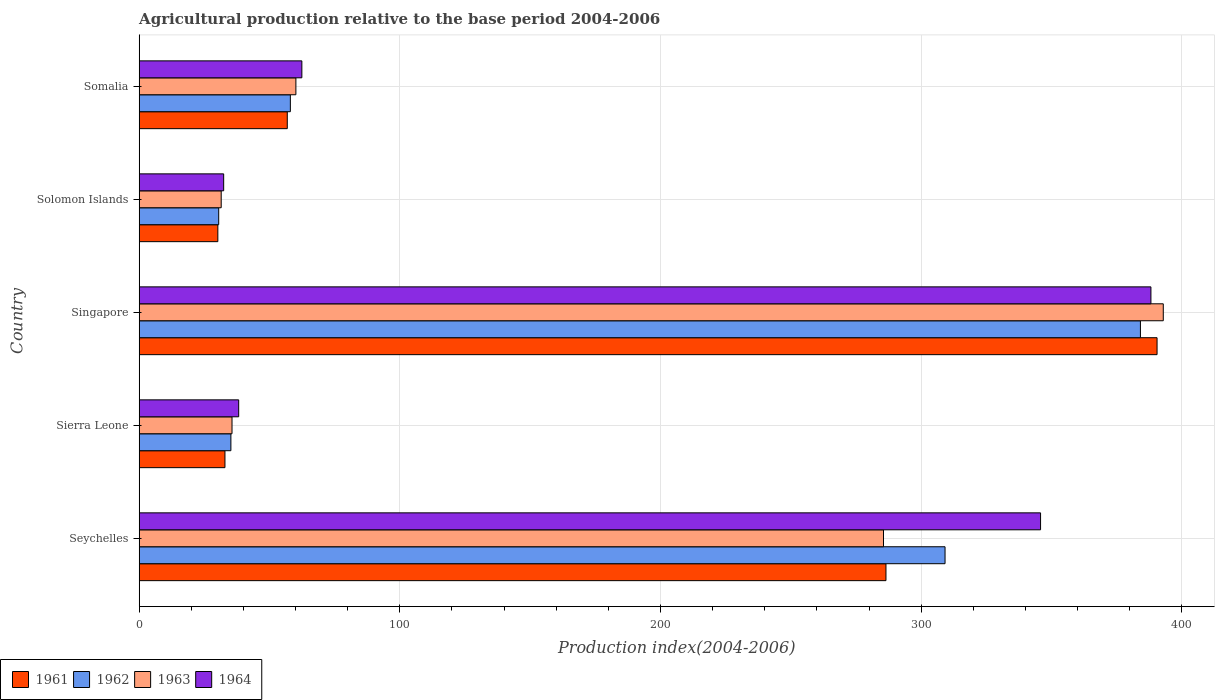Are the number of bars on each tick of the Y-axis equal?
Make the answer very short. Yes. How many bars are there on the 3rd tick from the top?
Make the answer very short. 4. How many bars are there on the 5th tick from the bottom?
Provide a succinct answer. 4. What is the label of the 2nd group of bars from the top?
Your response must be concise. Solomon Islands. What is the agricultural production index in 1964 in Singapore?
Your answer should be compact. 388.12. Across all countries, what is the maximum agricultural production index in 1962?
Give a very brief answer. 384.09. Across all countries, what is the minimum agricultural production index in 1963?
Your response must be concise. 31.47. In which country was the agricultural production index in 1962 maximum?
Give a very brief answer. Singapore. In which country was the agricultural production index in 1961 minimum?
Provide a short and direct response. Solomon Islands. What is the total agricultural production index in 1963 in the graph?
Give a very brief answer. 805.6. What is the difference between the agricultural production index in 1963 in Singapore and that in Somalia?
Give a very brief answer. 332.74. What is the difference between the agricultural production index in 1961 in Somalia and the agricultural production index in 1962 in Singapore?
Provide a short and direct response. -327.27. What is the average agricultural production index in 1964 per country?
Offer a terse response. 173.38. What is the difference between the agricultural production index in 1964 and agricultural production index in 1962 in Singapore?
Your answer should be very brief. 4.03. What is the ratio of the agricultural production index in 1963 in Seychelles to that in Somalia?
Keep it short and to the point. 4.75. Is the agricultural production index in 1963 in Sierra Leone less than that in Singapore?
Your response must be concise. Yes. Is the difference between the agricultural production index in 1964 in Singapore and Somalia greater than the difference between the agricultural production index in 1962 in Singapore and Somalia?
Your answer should be very brief. No. What is the difference between the highest and the second highest agricultural production index in 1964?
Make the answer very short. 42.34. What is the difference between the highest and the lowest agricultural production index in 1961?
Make the answer very short. 360.29. Is the sum of the agricultural production index in 1962 in Singapore and Somalia greater than the maximum agricultural production index in 1963 across all countries?
Your answer should be very brief. Yes. Is it the case that in every country, the sum of the agricultural production index in 1963 and agricultural production index in 1962 is greater than the sum of agricultural production index in 1964 and agricultural production index in 1961?
Provide a short and direct response. No. What does the 4th bar from the bottom in Somalia represents?
Ensure brevity in your answer.  1964. Is it the case that in every country, the sum of the agricultural production index in 1963 and agricultural production index in 1962 is greater than the agricultural production index in 1964?
Make the answer very short. Yes. How many bars are there?
Your answer should be compact. 20. What is the difference between two consecutive major ticks on the X-axis?
Give a very brief answer. 100. Does the graph contain any zero values?
Your answer should be compact. No. How many legend labels are there?
Make the answer very short. 4. What is the title of the graph?
Your answer should be compact. Agricultural production relative to the base period 2004-2006. What is the label or title of the X-axis?
Provide a short and direct response. Production index(2004-2006). What is the label or title of the Y-axis?
Provide a short and direct response. Country. What is the Production index(2004-2006) in 1961 in Seychelles?
Ensure brevity in your answer.  286.48. What is the Production index(2004-2006) of 1962 in Seychelles?
Your answer should be compact. 309.14. What is the Production index(2004-2006) in 1963 in Seychelles?
Provide a succinct answer. 285.53. What is the Production index(2004-2006) of 1964 in Seychelles?
Give a very brief answer. 345.78. What is the Production index(2004-2006) of 1961 in Sierra Leone?
Your answer should be compact. 32.91. What is the Production index(2004-2006) in 1962 in Sierra Leone?
Provide a short and direct response. 35.19. What is the Production index(2004-2006) in 1963 in Sierra Leone?
Offer a very short reply. 35.62. What is the Production index(2004-2006) in 1964 in Sierra Leone?
Provide a succinct answer. 38.18. What is the Production index(2004-2006) in 1961 in Singapore?
Ensure brevity in your answer.  390.47. What is the Production index(2004-2006) in 1962 in Singapore?
Provide a short and direct response. 384.09. What is the Production index(2004-2006) of 1963 in Singapore?
Offer a terse response. 392.86. What is the Production index(2004-2006) of 1964 in Singapore?
Provide a succinct answer. 388.12. What is the Production index(2004-2006) of 1961 in Solomon Islands?
Offer a very short reply. 30.18. What is the Production index(2004-2006) of 1962 in Solomon Islands?
Your response must be concise. 30.51. What is the Production index(2004-2006) of 1963 in Solomon Islands?
Keep it short and to the point. 31.47. What is the Production index(2004-2006) in 1964 in Solomon Islands?
Make the answer very short. 32.42. What is the Production index(2004-2006) of 1961 in Somalia?
Provide a succinct answer. 56.82. What is the Production index(2004-2006) in 1963 in Somalia?
Give a very brief answer. 60.12. What is the Production index(2004-2006) in 1964 in Somalia?
Your answer should be very brief. 62.41. Across all countries, what is the maximum Production index(2004-2006) in 1961?
Your response must be concise. 390.47. Across all countries, what is the maximum Production index(2004-2006) in 1962?
Your response must be concise. 384.09. Across all countries, what is the maximum Production index(2004-2006) of 1963?
Give a very brief answer. 392.86. Across all countries, what is the maximum Production index(2004-2006) in 1964?
Provide a short and direct response. 388.12. Across all countries, what is the minimum Production index(2004-2006) in 1961?
Ensure brevity in your answer.  30.18. Across all countries, what is the minimum Production index(2004-2006) of 1962?
Ensure brevity in your answer.  30.51. Across all countries, what is the minimum Production index(2004-2006) in 1963?
Provide a succinct answer. 31.47. Across all countries, what is the minimum Production index(2004-2006) in 1964?
Give a very brief answer. 32.42. What is the total Production index(2004-2006) of 1961 in the graph?
Give a very brief answer. 796.86. What is the total Production index(2004-2006) in 1962 in the graph?
Keep it short and to the point. 816.93. What is the total Production index(2004-2006) in 1963 in the graph?
Make the answer very short. 805.6. What is the total Production index(2004-2006) of 1964 in the graph?
Ensure brevity in your answer.  866.91. What is the difference between the Production index(2004-2006) of 1961 in Seychelles and that in Sierra Leone?
Your response must be concise. 253.57. What is the difference between the Production index(2004-2006) of 1962 in Seychelles and that in Sierra Leone?
Provide a short and direct response. 273.95. What is the difference between the Production index(2004-2006) of 1963 in Seychelles and that in Sierra Leone?
Provide a short and direct response. 249.91. What is the difference between the Production index(2004-2006) of 1964 in Seychelles and that in Sierra Leone?
Keep it short and to the point. 307.6. What is the difference between the Production index(2004-2006) in 1961 in Seychelles and that in Singapore?
Offer a very short reply. -103.99. What is the difference between the Production index(2004-2006) in 1962 in Seychelles and that in Singapore?
Offer a very short reply. -74.95. What is the difference between the Production index(2004-2006) in 1963 in Seychelles and that in Singapore?
Provide a short and direct response. -107.33. What is the difference between the Production index(2004-2006) of 1964 in Seychelles and that in Singapore?
Your response must be concise. -42.34. What is the difference between the Production index(2004-2006) in 1961 in Seychelles and that in Solomon Islands?
Make the answer very short. 256.3. What is the difference between the Production index(2004-2006) in 1962 in Seychelles and that in Solomon Islands?
Keep it short and to the point. 278.63. What is the difference between the Production index(2004-2006) in 1963 in Seychelles and that in Solomon Islands?
Your response must be concise. 254.06. What is the difference between the Production index(2004-2006) of 1964 in Seychelles and that in Solomon Islands?
Make the answer very short. 313.36. What is the difference between the Production index(2004-2006) in 1961 in Seychelles and that in Somalia?
Give a very brief answer. 229.66. What is the difference between the Production index(2004-2006) in 1962 in Seychelles and that in Somalia?
Offer a very short reply. 251.14. What is the difference between the Production index(2004-2006) of 1963 in Seychelles and that in Somalia?
Provide a succinct answer. 225.41. What is the difference between the Production index(2004-2006) of 1964 in Seychelles and that in Somalia?
Your response must be concise. 283.37. What is the difference between the Production index(2004-2006) of 1961 in Sierra Leone and that in Singapore?
Offer a terse response. -357.56. What is the difference between the Production index(2004-2006) in 1962 in Sierra Leone and that in Singapore?
Ensure brevity in your answer.  -348.9. What is the difference between the Production index(2004-2006) in 1963 in Sierra Leone and that in Singapore?
Your answer should be very brief. -357.24. What is the difference between the Production index(2004-2006) of 1964 in Sierra Leone and that in Singapore?
Your response must be concise. -349.94. What is the difference between the Production index(2004-2006) of 1961 in Sierra Leone and that in Solomon Islands?
Offer a terse response. 2.73. What is the difference between the Production index(2004-2006) in 1962 in Sierra Leone and that in Solomon Islands?
Your response must be concise. 4.68. What is the difference between the Production index(2004-2006) in 1963 in Sierra Leone and that in Solomon Islands?
Offer a terse response. 4.15. What is the difference between the Production index(2004-2006) of 1964 in Sierra Leone and that in Solomon Islands?
Provide a succinct answer. 5.76. What is the difference between the Production index(2004-2006) in 1961 in Sierra Leone and that in Somalia?
Your answer should be very brief. -23.91. What is the difference between the Production index(2004-2006) of 1962 in Sierra Leone and that in Somalia?
Provide a short and direct response. -22.81. What is the difference between the Production index(2004-2006) of 1963 in Sierra Leone and that in Somalia?
Your answer should be very brief. -24.5. What is the difference between the Production index(2004-2006) in 1964 in Sierra Leone and that in Somalia?
Offer a very short reply. -24.23. What is the difference between the Production index(2004-2006) of 1961 in Singapore and that in Solomon Islands?
Your response must be concise. 360.29. What is the difference between the Production index(2004-2006) in 1962 in Singapore and that in Solomon Islands?
Provide a succinct answer. 353.58. What is the difference between the Production index(2004-2006) in 1963 in Singapore and that in Solomon Islands?
Give a very brief answer. 361.39. What is the difference between the Production index(2004-2006) of 1964 in Singapore and that in Solomon Islands?
Keep it short and to the point. 355.7. What is the difference between the Production index(2004-2006) in 1961 in Singapore and that in Somalia?
Provide a short and direct response. 333.65. What is the difference between the Production index(2004-2006) of 1962 in Singapore and that in Somalia?
Offer a very short reply. 326.09. What is the difference between the Production index(2004-2006) in 1963 in Singapore and that in Somalia?
Give a very brief answer. 332.74. What is the difference between the Production index(2004-2006) in 1964 in Singapore and that in Somalia?
Offer a terse response. 325.71. What is the difference between the Production index(2004-2006) of 1961 in Solomon Islands and that in Somalia?
Provide a short and direct response. -26.64. What is the difference between the Production index(2004-2006) of 1962 in Solomon Islands and that in Somalia?
Offer a very short reply. -27.49. What is the difference between the Production index(2004-2006) in 1963 in Solomon Islands and that in Somalia?
Your answer should be very brief. -28.65. What is the difference between the Production index(2004-2006) of 1964 in Solomon Islands and that in Somalia?
Your response must be concise. -29.99. What is the difference between the Production index(2004-2006) in 1961 in Seychelles and the Production index(2004-2006) in 1962 in Sierra Leone?
Keep it short and to the point. 251.29. What is the difference between the Production index(2004-2006) in 1961 in Seychelles and the Production index(2004-2006) in 1963 in Sierra Leone?
Provide a succinct answer. 250.86. What is the difference between the Production index(2004-2006) in 1961 in Seychelles and the Production index(2004-2006) in 1964 in Sierra Leone?
Ensure brevity in your answer.  248.3. What is the difference between the Production index(2004-2006) in 1962 in Seychelles and the Production index(2004-2006) in 1963 in Sierra Leone?
Give a very brief answer. 273.52. What is the difference between the Production index(2004-2006) of 1962 in Seychelles and the Production index(2004-2006) of 1964 in Sierra Leone?
Ensure brevity in your answer.  270.96. What is the difference between the Production index(2004-2006) in 1963 in Seychelles and the Production index(2004-2006) in 1964 in Sierra Leone?
Ensure brevity in your answer.  247.35. What is the difference between the Production index(2004-2006) of 1961 in Seychelles and the Production index(2004-2006) of 1962 in Singapore?
Keep it short and to the point. -97.61. What is the difference between the Production index(2004-2006) in 1961 in Seychelles and the Production index(2004-2006) in 1963 in Singapore?
Keep it short and to the point. -106.38. What is the difference between the Production index(2004-2006) of 1961 in Seychelles and the Production index(2004-2006) of 1964 in Singapore?
Your answer should be compact. -101.64. What is the difference between the Production index(2004-2006) in 1962 in Seychelles and the Production index(2004-2006) in 1963 in Singapore?
Give a very brief answer. -83.72. What is the difference between the Production index(2004-2006) in 1962 in Seychelles and the Production index(2004-2006) in 1964 in Singapore?
Offer a very short reply. -78.98. What is the difference between the Production index(2004-2006) in 1963 in Seychelles and the Production index(2004-2006) in 1964 in Singapore?
Ensure brevity in your answer.  -102.59. What is the difference between the Production index(2004-2006) of 1961 in Seychelles and the Production index(2004-2006) of 1962 in Solomon Islands?
Offer a very short reply. 255.97. What is the difference between the Production index(2004-2006) of 1961 in Seychelles and the Production index(2004-2006) of 1963 in Solomon Islands?
Your answer should be compact. 255.01. What is the difference between the Production index(2004-2006) of 1961 in Seychelles and the Production index(2004-2006) of 1964 in Solomon Islands?
Keep it short and to the point. 254.06. What is the difference between the Production index(2004-2006) in 1962 in Seychelles and the Production index(2004-2006) in 1963 in Solomon Islands?
Give a very brief answer. 277.67. What is the difference between the Production index(2004-2006) in 1962 in Seychelles and the Production index(2004-2006) in 1964 in Solomon Islands?
Provide a short and direct response. 276.72. What is the difference between the Production index(2004-2006) of 1963 in Seychelles and the Production index(2004-2006) of 1964 in Solomon Islands?
Your answer should be compact. 253.11. What is the difference between the Production index(2004-2006) in 1961 in Seychelles and the Production index(2004-2006) in 1962 in Somalia?
Give a very brief answer. 228.48. What is the difference between the Production index(2004-2006) of 1961 in Seychelles and the Production index(2004-2006) of 1963 in Somalia?
Your response must be concise. 226.36. What is the difference between the Production index(2004-2006) in 1961 in Seychelles and the Production index(2004-2006) in 1964 in Somalia?
Your answer should be compact. 224.07. What is the difference between the Production index(2004-2006) in 1962 in Seychelles and the Production index(2004-2006) in 1963 in Somalia?
Keep it short and to the point. 249.02. What is the difference between the Production index(2004-2006) in 1962 in Seychelles and the Production index(2004-2006) in 1964 in Somalia?
Your response must be concise. 246.73. What is the difference between the Production index(2004-2006) in 1963 in Seychelles and the Production index(2004-2006) in 1964 in Somalia?
Your answer should be compact. 223.12. What is the difference between the Production index(2004-2006) in 1961 in Sierra Leone and the Production index(2004-2006) in 1962 in Singapore?
Give a very brief answer. -351.18. What is the difference between the Production index(2004-2006) of 1961 in Sierra Leone and the Production index(2004-2006) of 1963 in Singapore?
Your answer should be compact. -359.95. What is the difference between the Production index(2004-2006) of 1961 in Sierra Leone and the Production index(2004-2006) of 1964 in Singapore?
Ensure brevity in your answer.  -355.21. What is the difference between the Production index(2004-2006) of 1962 in Sierra Leone and the Production index(2004-2006) of 1963 in Singapore?
Keep it short and to the point. -357.67. What is the difference between the Production index(2004-2006) in 1962 in Sierra Leone and the Production index(2004-2006) in 1964 in Singapore?
Provide a succinct answer. -352.93. What is the difference between the Production index(2004-2006) in 1963 in Sierra Leone and the Production index(2004-2006) in 1964 in Singapore?
Your response must be concise. -352.5. What is the difference between the Production index(2004-2006) in 1961 in Sierra Leone and the Production index(2004-2006) in 1962 in Solomon Islands?
Offer a very short reply. 2.4. What is the difference between the Production index(2004-2006) in 1961 in Sierra Leone and the Production index(2004-2006) in 1963 in Solomon Islands?
Provide a short and direct response. 1.44. What is the difference between the Production index(2004-2006) in 1961 in Sierra Leone and the Production index(2004-2006) in 1964 in Solomon Islands?
Your answer should be very brief. 0.49. What is the difference between the Production index(2004-2006) of 1962 in Sierra Leone and the Production index(2004-2006) of 1963 in Solomon Islands?
Your answer should be very brief. 3.72. What is the difference between the Production index(2004-2006) of 1962 in Sierra Leone and the Production index(2004-2006) of 1964 in Solomon Islands?
Your answer should be compact. 2.77. What is the difference between the Production index(2004-2006) of 1963 in Sierra Leone and the Production index(2004-2006) of 1964 in Solomon Islands?
Provide a succinct answer. 3.2. What is the difference between the Production index(2004-2006) in 1961 in Sierra Leone and the Production index(2004-2006) in 1962 in Somalia?
Your answer should be very brief. -25.09. What is the difference between the Production index(2004-2006) of 1961 in Sierra Leone and the Production index(2004-2006) of 1963 in Somalia?
Keep it short and to the point. -27.21. What is the difference between the Production index(2004-2006) in 1961 in Sierra Leone and the Production index(2004-2006) in 1964 in Somalia?
Offer a terse response. -29.5. What is the difference between the Production index(2004-2006) of 1962 in Sierra Leone and the Production index(2004-2006) of 1963 in Somalia?
Make the answer very short. -24.93. What is the difference between the Production index(2004-2006) in 1962 in Sierra Leone and the Production index(2004-2006) in 1964 in Somalia?
Your answer should be compact. -27.22. What is the difference between the Production index(2004-2006) of 1963 in Sierra Leone and the Production index(2004-2006) of 1964 in Somalia?
Provide a short and direct response. -26.79. What is the difference between the Production index(2004-2006) in 1961 in Singapore and the Production index(2004-2006) in 1962 in Solomon Islands?
Offer a very short reply. 359.96. What is the difference between the Production index(2004-2006) of 1961 in Singapore and the Production index(2004-2006) of 1963 in Solomon Islands?
Offer a very short reply. 359. What is the difference between the Production index(2004-2006) in 1961 in Singapore and the Production index(2004-2006) in 1964 in Solomon Islands?
Your answer should be compact. 358.05. What is the difference between the Production index(2004-2006) of 1962 in Singapore and the Production index(2004-2006) of 1963 in Solomon Islands?
Provide a succinct answer. 352.62. What is the difference between the Production index(2004-2006) in 1962 in Singapore and the Production index(2004-2006) in 1964 in Solomon Islands?
Make the answer very short. 351.67. What is the difference between the Production index(2004-2006) of 1963 in Singapore and the Production index(2004-2006) of 1964 in Solomon Islands?
Provide a succinct answer. 360.44. What is the difference between the Production index(2004-2006) in 1961 in Singapore and the Production index(2004-2006) in 1962 in Somalia?
Give a very brief answer. 332.47. What is the difference between the Production index(2004-2006) of 1961 in Singapore and the Production index(2004-2006) of 1963 in Somalia?
Provide a succinct answer. 330.35. What is the difference between the Production index(2004-2006) in 1961 in Singapore and the Production index(2004-2006) in 1964 in Somalia?
Provide a succinct answer. 328.06. What is the difference between the Production index(2004-2006) of 1962 in Singapore and the Production index(2004-2006) of 1963 in Somalia?
Your answer should be compact. 323.97. What is the difference between the Production index(2004-2006) of 1962 in Singapore and the Production index(2004-2006) of 1964 in Somalia?
Give a very brief answer. 321.68. What is the difference between the Production index(2004-2006) in 1963 in Singapore and the Production index(2004-2006) in 1964 in Somalia?
Give a very brief answer. 330.45. What is the difference between the Production index(2004-2006) in 1961 in Solomon Islands and the Production index(2004-2006) in 1962 in Somalia?
Offer a terse response. -27.82. What is the difference between the Production index(2004-2006) of 1961 in Solomon Islands and the Production index(2004-2006) of 1963 in Somalia?
Provide a succinct answer. -29.94. What is the difference between the Production index(2004-2006) in 1961 in Solomon Islands and the Production index(2004-2006) in 1964 in Somalia?
Your answer should be very brief. -32.23. What is the difference between the Production index(2004-2006) in 1962 in Solomon Islands and the Production index(2004-2006) in 1963 in Somalia?
Offer a very short reply. -29.61. What is the difference between the Production index(2004-2006) in 1962 in Solomon Islands and the Production index(2004-2006) in 1964 in Somalia?
Provide a succinct answer. -31.9. What is the difference between the Production index(2004-2006) of 1963 in Solomon Islands and the Production index(2004-2006) of 1964 in Somalia?
Offer a terse response. -30.94. What is the average Production index(2004-2006) in 1961 per country?
Offer a very short reply. 159.37. What is the average Production index(2004-2006) of 1962 per country?
Provide a succinct answer. 163.39. What is the average Production index(2004-2006) of 1963 per country?
Ensure brevity in your answer.  161.12. What is the average Production index(2004-2006) of 1964 per country?
Keep it short and to the point. 173.38. What is the difference between the Production index(2004-2006) of 1961 and Production index(2004-2006) of 1962 in Seychelles?
Keep it short and to the point. -22.66. What is the difference between the Production index(2004-2006) of 1961 and Production index(2004-2006) of 1963 in Seychelles?
Keep it short and to the point. 0.95. What is the difference between the Production index(2004-2006) in 1961 and Production index(2004-2006) in 1964 in Seychelles?
Offer a terse response. -59.3. What is the difference between the Production index(2004-2006) of 1962 and Production index(2004-2006) of 1963 in Seychelles?
Keep it short and to the point. 23.61. What is the difference between the Production index(2004-2006) of 1962 and Production index(2004-2006) of 1964 in Seychelles?
Give a very brief answer. -36.64. What is the difference between the Production index(2004-2006) of 1963 and Production index(2004-2006) of 1964 in Seychelles?
Ensure brevity in your answer.  -60.25. What is the difference between the Production index(2004-2006) of 1961 and Production index(2004-2006) of 1962 in Sierra Leone?
Keep it short and to the point. -2.28. What is the difference between the Production index(2004-2006) of 1961 and Production index(2004-2006) of 1963 in Sierra Leone?
Provide a succinct answer. -2.71. What is the difference between the Production index(2004-2006) of 1961 and Production index(2004-2006) of 1964 in Sierra Leone?
Make the answer very short. -5.27. What is the difference between the Production index(2004-2006) in 1962 and Production index(2004-2006) in 1963 in Sierra Leone?
Provide a short and direct response. -0.43. What is the difference between the Production index(2004-2006) in 1962 and Production index(2004-2006) in 1964 in Sierra Leone?
Provide a short and direct response. -2.99. What is the difference between the Production index(2004-2006) in 1963 and Production index(2004-2006) in 1964 in Sierra Leone?
Provide a succinct answer. -2.56. What is the difference between the Production index(2004-2006) of 1961 and Production index(2004-2006) of 1962 in Singapore?
Your answer should be compact. 6.38. What is the difference between the Production index(2004-2006) of 1961 and Production index(2004-2006) of 1963 in Singapore?
Ensure brevity in your answer.  -2.39. What is the difference between the Production index(2004-2006) in 1961 and Production index(2004-2006) in 1964 in Singapore?
Offer a very short reply. 2.35. What is the difference between the Production index(2004-2006) in 1962 and Production index(2004-2006) in 1963 in Singapore?
Your answer should be very brief. -8.77. What is the difference between the Production index(2004-2006) of 1962 and Production index(2004-2006) of 1964 in Singapore?
Ensure brevity in your answer.  -4.03. What is the difference between the Production index(2004-2006) of 1963 and Production index(2004-2006) of 1964 in Singapore?
Ensure brevity in your answer.  4.74. What is the difference between the Production index(2004-2006) in 1961 and Production index(2004-2006) in 1962 in Solomon Islands?
Your answer should be very brief. -0.33. What is the difference between the Production index(2004-2006) of 1961 and Production index(2004-2006) of 1963 in Solomon Islands?
Keep it short and to the point. -1.29. What is the difference between the Production index(2004-2006) of 1961 and Production index(2004-2006) of 1964 in Solomon Islands?
Offer a very short reply. -2.24. What is the difference between the Production index(2004-2006) of 1962 and Production index(2004-2006) of 1963 in Solomon Islands?
Your response must be concise. -0.96. What is the difference between the Production index(2004-2006) in 1962 and Production index(2004-2006) in 1964 in Solomon Islands?
Give a very brief answer. -1.91. What is the difference between the Production index(2004-2006) of 1963 and Production index(2004-2006) of 1964 in Solomon Islands?
Give a very brief answer. -0.95. What is the difference between the Production index(2004-2006) of 1961 and Production index(2004-2006) of 1962 in Somalia?
Your response must be concise. -1.18. What is the difference between the Production index(2004-2006) in 1961 and Production index(2004-2006) in 1963 in Somalia?
Make the answer very short. -3.3. What is the difference between the Production index(2004-2006) of 1961 and Production index(2004-2006) of 1964 in Somalia?
Make the answer very short. -5.59. What is the difference between the Production index(2004-2006) in 1962 and Production index(2004-2006) in 1963 in Somalia?
Provide a short and direct response. -2.12. What is the difference between the Production index(2004-2006) in 1962 and Production index(2004-2006) in 1964 in Somalia?
Provide a succinct answer. -4.41. What is the difference between the Production index(2004-2006) in 1963 and Production index(2004-2006) in 1964 in Somalia?
Ensure brevity in your answer.  -2.29. What is the ratio of the Production index(2004-2006) in 1961 in Seychelles to that in Sierra Leone?
Give a very brief answer. 8.71. What is the ratio of the Production index(2004-2006) of 1962 in Seychelles to that in Sierra Leone?
Make the answer very short. 8.78. What is the ratio of the Production index(2004-2006) of 1963 in Seychelles to that in Sierra Leone?
Make the answer very short. 8.02. What is the ratio of the Production index(2004-2006) of 1964 in Seychelles to that in Sierra Leone?
Give a very brief answer. 9.06. What is the ratio of the Production index(2004-2006) in 1961 in Seychelles to that in Singapore?
Make the answer very short. 0.73. What is the ratio of the Production index(2004-2006) in 1962 in Seychelles to that in Singapore?
Your answer should be compact. 0.8. What is the ratio of the Production index(2004-2006) in 1963 in Seychelles to that in Singapore?
Your answer should be very brief. 0.73. What is the ratio of the Production index(2004-2006) of 1964 in Seychelles to that in Singapore?
Offer a very short reply. 0.89. What is the ratio of the Production index(2004-2006) of 1961 in Seychelles to that in Solomon Islands?
Ensure brevity in your answer.  9.49. What is the ratio of the Production index(2004-2006) in 1962 in Seychelles to that in Solomon Islands?
Offer a terse response. 10.13. What is the ratio of the Production index(2004-2006) in 1963 in Seychelles to that in Solomon Islands?
Ensure brevity in your answer.  9.07. What is the ratio of the Production index(2004-2006) in 1964 in Seychelles to that in Solomon Islands?
Offer a very short reply. 10.67. What is the ratio of the Production index(2004-2006) of 1961 in Seychelles to that in Somalia?
Make the answer very short. 5.04. What is the ratio of the Production index(2004-2006) of 1962 in Seychelles to that in Somalia?
Make the answer very short. 5.33. What is the ratio of the Production index(2004-2006) in 1963 in Seychelles to that in Somalia?
Keep it short and to the point. 4.75. What is the ratio of the Production index(2004-2006) of 1964 in Seychelles to that in Somalia?
Your answer should be compact. 5.54. What is the ratio of the Production index(2004-2006) in 1961 in Sierra Leone to that in Singapore?
Keep it short and to the point. 0.08. What is the ratio of the Production index(2004-2006) of 1962 in Sierra Leone to that in Singapore?
Provide a succinct answer. 0.09. What is the ratio of the Production index(2004-2006) of 1963 in Sierra Leone to that in Singapore?
Make the answer very short. 0.09. What is the ratio of the Production index(2004-2006) of 1964 in Sierra Leone to that in Singapore?
Your answer should be very brief. 0.1. What is the ratio of the Production index(2004-2006) of 1961 in Sierra Leone to that in Solomon Islands?
Make the answer very short. 1.09. What is the ratio of the Production index(2004-2006) in 1962 in Sierra Leone to that in Solomon Islands?
Offer a very short reply. 1.15. What is the ratio of the Production index(2004-2006) of 1963 in Sierra Leone to that in Solomon Islands?
Make the answer very short. 1.13. What is the ratio of the Production index(2004-2006) in 1964 in Sierra Leone to that in Solomon Islands?
Provide a succinct answer. 1.18. What is the ratio of the Production index(2004-2006) of 1961 in Sierra Leone to that in Somalia?
Offer a terse response. 0.58. What is the ratio of the Production index(2004-2006) of 1962 in Sierra Leone to that in Somalia?
Provide a succinct answer. 0.61. What is the ratio of the Production index(2004-2006) in 1963 in Sierra Leone to that in Somalia?
Offer a terse response. 0.59. What is the ratio of the Production index(2004-2006) of 1964 in Sierra Leone to that in Somalia?
Provide a succinct answer. 0.61. What is the ratio of the Production index(2004-2006) of 1961 in Singapore to that in Solomon Islands?
Provide a succinct answer. 12.94. What is the ratio of the Production index(2004-2006) of 1962 in Singapore to that in Solomon Islands?
Your response must be concise. 12.59. What is the ratio of the Production index(2004-2006) in 1963 in Singapore to that in Solomon Islands?
Offer a terse response. 12.48. What is the ratio of the Production index(2004-2006) of 1964 in Singapore to that in Solomon Islands?
Provide a succinct answer. 11.97. What is the ratio of the Production index(2004-2006) of 1961 in Singapore to that in Somalia?
Provide a short and direct response. 6.87. What is the ratio of the Production index(2004-2006) of 1962 in Singapore to that in Somalia?
Provide a short and direct response. 6.62. What is the ratio of the Production index(2004-2006) in 1963 in Singapore to that in Somalia?
Provide a succinct answer. 6.53. What is the ratio of the Production index(2004-2006) of 1964 in Singapore to that in Somalia?
Keep it short and to the point. 6.22. What is the ratio of the Production index(2004-2006) in 1961 in Solomon Islands to that in Somalia?
Your response must be concise. 0.53. What is the ratio of the Production index(2004-2006) in 1962 in Solomon Islands to that in Somalia?
Offer a very short reply. 0.53. What is the ratio of the Production index(2004-2006) of 1963 in Solomon Islands to that in Somalia?
Offer a very short reply. 0.52. What is the ratio of the Production index(2004-2006) of 1964 in Solomon Islands to that in Somalia?
Make the answer very short. 0.52. What is the difference between the highest and the second highest Production index(2004-2006) in 1961?
Offer a very short reply. 103.99. What is the difference between the highest and the second highest Production index(2004-2006) of 1962?
Make the answer very short. 74.95. What is the difference between the highest and the second highest Production index(2004-2006) in 1963?
Your response must be concise. 107.33. What is the difference between the highest and the second highest Production index(2004-2006) of 1964?
Offer a very short reply. 42.34. What is the difference between the highest and the lowest Production index(2004-2006) in 1961?
Your answer should be compact. 360.29. What is the difference between the highest and the lowest Production index(2004-2006) of 1962?
Offer a terse response. 353.58. What is the difference between the highest and the lowest Production index(2004-2006) of 1963?
Your answer should be compact. 361.39. What is the difference between the highest and the lowest Production index(2004-2006) of 1964?
Make the answer very short. 355.7. 